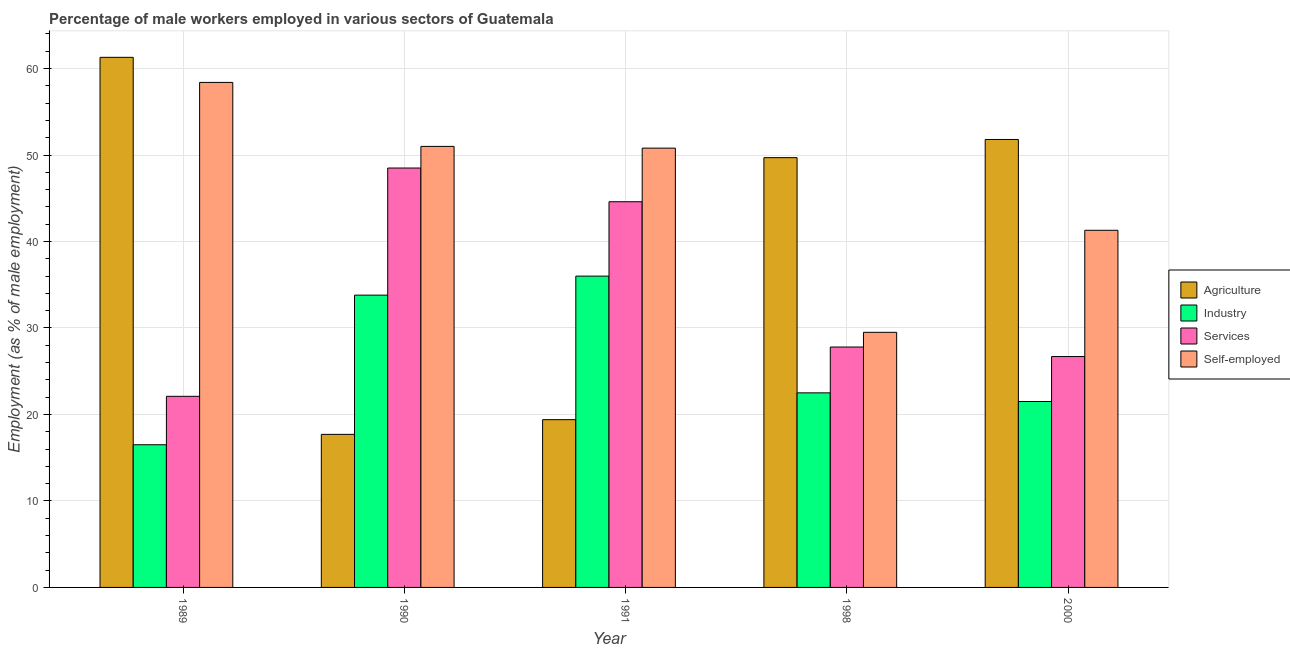How many bars are there on the 4th tick from the left?
Give a very brief answer. 4. What is the percentage of self employed male workers in 1989?
Your response must be concise. 58.4. Across all years, what is the maximum percentage of self employed male workers?
Keep it short and to the point. 58.4. Across all years, what is the minimum percentage of male workers in services?
Offer a terse response. 22.1. In which year was the percentage of male workers in services maximum?
Keep it short and to the point. 1990. What is the total percentage of male workers in industry in the graph?
Offer a very short reply. 130.3. What is the difference between the percentage of male workers in services in 1991 and that in 1998?
Give a very brief answer. 16.8. What is the difference between the percentage of male workers in services in 1990 and the percentage of self employed male workers in 2000?
Your answer should be very brief. 21.8. What is the average percentage of male workers in agriculture per year?
Ensure brevity in your answer.  39.98. In how many years, is the percentage of male workers in industry greater than 50 %?
Your answer should be compact. 0. What is the ratio of the percentage of male workers in services in 1989 to that in 2000?
Your answer should be compact. 0.83. Is the percentage of male workers in agriculture in 1990 less than that in 1991?
Provide a succinct answer. Yes. Is the difference between the percentage of self employed male workers in 1989 and 1991 greater than the difference between the percentage of male workers in agriculture in 1989 and 1991?
Your answer should be compact. No. What is the difference between the highest and the second highest percentage of male workers in agriculture?
Keep it short and to the point. 9.5. What is the difference between the highest and the lowest percentage of male workers in agriculture?
Provide a succinct answer. 43.6. Is the sum of the percentage of self employed male workers in 1991 and 1998 greater than the maximum percentage of male workers in services across all years?
Your response must be concise. Yes. Is it the case that in every year, the sum of the percentage of male workers in services and percentage of self employed male workers is greater than the sum of percentage of male workers in industry and percentage of male workers in agriculture?
Make the answer very short. No. What does the 4th bar from the left in 1990 represents?
Your answer should be very brief. Self-employed. What does the 3rd bar from the right in 2000 represents?
Offer a terse response. Industry. How many years are there in the graph?
Provide a succinct answer. 5. Does the graph contain any zero values?
Your response must be concise. No. Does the graph contain grids?
Your answer should be compact. Yes. Where does the legend appear in the graph?
Make the answer very short. Center right. What is the title of the graph?
Offer a very short reply. Percentage of male workers employed in various sectors of Guatemala. What is the label or title of the X-axis?
Give a very brief answer. Year. What is the label or title of the Y-axis?
Your answer should be very brief. Employment (as % of male employment). What is the Employment (as % of male employment) of Agriculture in 1989?
Give a very brief answer. 61.3. What is the Employment (as % of male employment) of Industry in 1989?
Give a very brief answer. 16.5. What is the Employment (as % of male employment) of Services in 1989?
Give a very brief answer. 22.1. What is the Employment (as % of male employment) in Self-employed in 1989?
Your response must be concise. 58.4. What is the Employment (as % of male employment) in Agriculture in 1990?
Make the answer very short. 17.7. What is the Employment (as % of male employment) in Industry in 1990?
Provide a short and direct response. 33.8. What is the Employment (as % of male employment) of Services in 1990?
Offer a very short reply. 48.5. What is the Employment (as % of male employment) of Agriculture in 1991?
Your answer should be compact. 19.4. What is the Employment (as % of male employment) in Industry in 1991?
Make the answer very short. 36. What is the Employment (as % of male employment) of Services in 1991?
Your response must be concise. 44.6. What is the Employment (as % of male employment) in Self-employed in 1991?
Your response must be concise. 50.8. What is the Employment (as % of male employment) in Agriculture in 1998?
Give a very brief answer. 49.7. What is the Employment (as % of male employment) in Services in 1998?
Ensure brevity in your answer.  27.8. What is the Employment (as % of male employment) in Self-employed in 1998?
Give a very brief answer. 29.5. What is the Employment (as % of male employment) of Agriculture in 2000?
Your answer should be very brief. 51.8. What is the Employment (as % of male employment) in Services in 2000?
Make the answer very short. 26.7. What is the Employment (as % of male employment) in Self-employed in 2000?
Make the answer very short. 41.3. Across all years, what is the maximum Employment (as % of male employment) of Agriculture?
Ensure brevity in your answer.  61.3. Across all years, what is the maximum Employment (as % of male employment) of Services?
Provide a succinct answer. 48.5. Across all years, what is the maximum Employment (as % of male employment) in Self-employed?
Give a very brief answer. 58.4. Across all years, what is the minimum Employment (as % of male employment) of Agriculture?
Your answer should be compact. 17.7. Across all years, what is the minimum Employment (as % of male employment) of Services?
Offer a terse response. 22.1. Across all years, what is the minimum Employment (as % of male employment) of Self-employed?
Your response must be concise. 29.5. What is the total Employment (as % of male employment) of Agriculture in the graph?
Give a very brief answer. 199.9. What is the total Employment (as % of male employment) in Industry in the graph?
Your answer should be very brief. 130.3. What is the total Employment (as % of male employment) of Services in the graph?
Offer a very short reply. 169.7. What is the total Employment (as % of male employment) in Self-employed in the graph?
Your answer should be very brief. 231. What is the difference between the Employment (as % of male employment) in Agriculture in 1989 and that in 1990?
Keep it short and to the point. 43.6. What is the difference between the Employment (as % of male employment) of Industry in 1989 and that in 1990?
Your answer should be very brief. -17.3. What is the difference between the Employment (as % of male employment) of Services in 1989 and that in 1990?
Ensure brevity in your answer.  -26.4. What is the difference between the Employment (as % of male employment) of Agriculture in 1989 and that in 1991?
Offer a terse response. 41.9. What is the difference between the Employment (as % of male employment) in Industry in 1989 and that in 1991?
Your response must be concise. -19.5. What is the difference between the Employment (as % of male employment) of Services in 1989 and that in 1991?
Give a very brief answer. -22.5. What is the difference between the Employment (as % of male employment) in Self-employed in 1989 and that in 1998?
Make the answer very short. 28.9. What is the difference between the Employment (as % of male employment) of Agriculture in 1989 and that in 2000?
Offer a terse response. 9.5. What is the difference between the Employment (as % of male employment) in Industry in 1989 and that in 2000?
Make the answer very short. -5. What is the difference between the Employment (as % of male employment) of Self-employed in 1989 and that in 2000?
Provide a short and direct response. 17.1. What is the difference between the Employment (as % of male employment) of Industry in 1990 and that in 1991?
Provide a short and direct response. -2.2. What is the difference between the Employment (as % of male employment) in Agriculture in 1990 and that in 1998?
Offer a terse response. -32. What is the difference between the Employment (as % of male employment) of Industry in 1990 and that in 1998?
Keep it short and to the point. 11.3. What is the difference between the Employment (as % of male employment) in Services in 1990 and that in 1998?
Offer a very short reply. 20.7. What is the difference between the Employment (as % of male employment) in Agriculture in 1990 and that in 2000?
Give a very brief answer. -34.1. What is the difference between the Employment (as % of male employment) of Industry in 1990 and that in 2000?
Offer a very short reply. 12.3. What is the difference between the Employment (as % of male employment) in Services in 1990 and that in 2000?
Offer a terse response. 21.8. What is the difference between the Employment (as % of male employment) of Agriculture in 1991 and that in 1998?
Offer a very short reply. -30.3. What is the difference between the Employment (as % of male employment) in Self-employed in 1991 and that in 1998?
Ensure brevity in your answer.  21.3. What is the difference between the Employment (as % of male employment) in Agriculture in 1991 and that in 2000?
Keep it short and to the point. -32.4. What is the difference between the Employment (as % of male employment) of Industry in 1991 and that in 2000?
Provide a short and direct response. 14.5. What is the difference between the Employment (as % of male employment) of Services in 1991 and that in 2000?
Offer a terse response. 17.9. What is the difference between the Employment (as % of male employment) in Agriculture in 1998 and that in 2000?
Give a very brief answer. -2.1. What is the difference between the Employment (as % of male employment) of Agriculture in 1989 and the Employment (as % of male employment) of Services in 1990?
Your response must be concise. 12.8. What is the difference between the Employment (as % of male employment) in Agriculture in 1989 and the Employment (as % of male employment) in Self-employed in 1990?
Make the answer very short. 10.3. What is the difference between the Employment (as % of male employment) of Industry in 1989 and the Employment (as % of male employment) of Services in 1990?
Your answer should be very brief. -32. What is the difference between the Employment (as % of male employment) of Industry in 1989 and the Employment (as % of male employment) of Self-employed in 1990?
Your answer should be very brief. -34.5. What is the difference between the Employment (as % of male employment) in Services in 1989 and the Employment (as % of male employment) in Self-employed in 1990?
Your answer should be compact. -28.9. What is the difference between the Employment (as % of male employment) of Agriculture in 1989 and the Employment (as % of male employment) of Industry in 1991?
Ensure brevity in your answer.  25.3. What is the difference between the Employment (as % of male employment) of Agriculture in 1989 and the Employment (as % of male employment) of Services in 1991?
Keep it short and to the point. 16.7. What is the difference between the Employment (as % of male employment) in Industry in 1989 and the Employment (as % of male employment) in Services in 1991?
Make the answer very short. -28.1. What is the difference between the Employment (as % of male employment) in Industry in 1989 and the Employment (as % of male employment) in Self-employed in 1991?
Your response must be concise. -34.3. What is the difference between the Employment (as % of male employment) in Services in 1989 and the Employment (as % of male employment) in Self-employed in 1991?
Keep it short and to the point. -28.7. What is the difference between the Employment (as % of male employment) of Agriculture in 1989 and the Employment (as % of male employment) of Industry in 1998?
Your answer should be very brief. 38.8. What is the difference between the Employment (as % of male employment) of Agriculture in 1989 and the Employment (as % of male employment) of Services in 1998?
Ensure brevity in your answer.  33.5. What is the difference between the Employment (as % of male employment) in Agriculture in 1989 and the Employment (as % of male employment) in Self-employed in 1998?
Offer a very short reply. 31.8. What is the difference between the Employment (as % of male employment) in Industry in 1989 and the Employment (as % of male employment) in Services in 1998?
Give a very brief answer. -11.3. What is the difference between the Employment (as % of male employment) in Industry in 1989 and the Employment (as % of male employment) in Self-employed in 1998?
Your answer should be compact. -13. What is the difference between the Employment (as % of male employment) in Agriculture in 1989 and the Employment (as % of male employment) in Industry in 2000?
Keep it short and to the point. 39.8. What is the difference between the Employment (as % of male employment) of Agriculture in 1989 and the Employment (as % of male employment) of Services in 2000?
Ensure brevity in your answer.  34.6. What is the difference between the Employment (as % of male employment) in Agriculture in 1989 and the Employment (as % of male employment) in Self-employed in 2000?
Ensure brevity in your answer.  20. What is the difference between the Employment (as % of male employment) of Industry in 1989 and the Employment (as % of male employment) of Services in 2000?
Your response must be concise. -10.2. What is the difference between the Employment (as % of male employment) of Industry in 1989 and the Employment (as % of male employment) of Self-employed in 2000?
Offer a terse response. -24.8. What is the difference between the Employment (as % of male employment) of Services in 1989 and the Employment (as % of male employment) of Self-employed in 2000?
Offer a terse response. -19.2. What is the difference between the Employment (as % of male employment) of Agriculture in 1990 and the Employment (as % of male employment) of Industry in 1991?
Give a very brief answer. -18.3. What is the difference between the Employment (as % of male employment) of Agriculture in 1990 and the Employment (as % of male employment) of Services in 1991?
Provide a short and direct response. -26.9. What is the difference between the Employment (as % of male employment) in Agriculture in 1990 and the Employment (as % of male employment) in Self-employed in 1991?
Give a very brief answer. -33.1. What is the difference between the Employment (as % of male employment) in Industry in 1990 and the Employment (as % of male employment) in Services in 1998?
Provide a succinct answer. 6. What is the difference between the Employment (as % of male employment) in Industry in 1990 and the Employment (as % of male employment) in Self-employed in 1998?
Provide a succinct answer. 4.3. What is the difference between the Employment (as % of male employment) in Agriculture in 1990 and the Employment (as % of male employment) in Services in 2000?
Ensure brevity in your answer.  -9. What is the difference between the Employment (as % of male employment) of Agriculture in 1990 and the Employment (as % of male employment) of Self-employed in 2000?
Your answer should be very brief. -23.6. What is the difference between the Employment (as % of male employment) of Industry in 1990 and the Employment (as % of male employment) of Self-employed in 2000?
Offer a very short reply. -7.5. What is the difference between the Employment (as % of male employment) in Services in 1990 and the Employment (as % of male employment) in Self-employed in 2000?
Offer a terse response. 7.2. What is the difference between the Employment (as % of male employment) in Agriculture in 1991 and the Employment (as % of male employment) in Self-employed in 1998?
Provide a succinct answer. -10.1. What is the difference between the Employment (as % of male employment) of Agriculture in 1991 and the Employment (as % of male employment) of Self-employed in 2000?
Your response must be concise. -21.9. What is the difference between the Employment (as % of male employment) in Agriculture in 1998 and the Employment (as % of male employment) in Industry in 2000?
Provide a succinct answer. 28.2. What is the difference between the Employment (as % of male employment) in Agriculture in 1998 and the Employment (as % of male employment) in Self-employed in 2000?
Provide a succinct answer. 8.4. What is the difference between the Employment (as % of male employment) in Industry in 1998 and the Employment (as % of male employment) in Self-employed in 2000?
Give a very brief answer. -18.8. What is the average Employment (as % of male employment) of Agriculture per year?
Offer a terse response. 39.98. What is the average Employment (as % of male employment) in Industry per year?
Your answer should be compact. 26.06. What is the average Employment (as % of male employment) in Services per year?
Your answer should be compact. 33.94. What is the average Employment (as % of male employment) in Self-employed per year?
Give a very brief answer. 46.2. In the year 1989, what is the difference between the Employment (as % of male employment) of Agriculture and Employment (as % of male employment) of Industry?
Make the answer very short. 44.8. In the year 1989, what is the difference between the Employment (as % of male employment) of Agriculture and Employment (as % of male employment) of Services?
Make the answer very short. 39.2. In the year 1989, what is the difference between the Employment (as % of male employment) of Agriculture and Employment (as % of male employment) of Self-employed?
Give a very brief answer. 2.9. In the year 1989, what is the difference between the Employment (as % of male employment) of Industry and Employment (as % of male employment) of Services?
Your answer should be very brief. -5.6. In the year 1989, what is the difference between the Employment (as % of male employment) of Industry and Employment (as % of male employment) of Self-employed?
Provide a short and direct response. -41.9. In the year 1989, what is the difference between the Employment (as % of male employment) of Services and Employment (as % of male employment) of Self-employed?
Offer a terse response. -36.3. In the year 1990, what is the difference between the Employment (as % of male employment) in Agriculture and Employment (as % of male employment) in Industry?
Offer a very short reply. -16.1. In the year 1990, what is the difference between the Employment (as % of male employment) in Agriculture and Employment (as % of male employment) in Services?
Offer a terse response. -30.8. In the year 1990, what is the difference between the Employment (as % of male employment) in Agriculture and Employment (as % of male employment) in Self-employed?
Your answer should be very brief. -33.3. In the year 1990, what is the difference between the Employment (as % of male employment) of Industry and Employment (as % of male employment) of Services?
Provide a short and direct response. -14.7. In the year 1990, what is the difference between the Employment (as % of male employment) in Industry and Employment (as % of male employment) in Self-employed?
Offer a very short reply. -17.2. In the year 1990, what is the difference between the Employment (as % of male employment) of Services and Employment (as % of male employment) of Self-employed?
Offer a terse response. -2.5. In the year 1991, what is the difference between the Employment (as % of male employment) in Agriculture and Employment (as % of male employment) in Industry?
Ensure brevity in your answer.  -16.6. In the year 1991, what is the difference between the Employment (as % of male employment) of Agriculture and Employment (as % of male employment) of Services?
Keep it short and to the point. -25.2. In the year 1991, what is the difference between the Employment (as % of male employment) of Agriculture and Employment (as % of male employment) of Self-employed?
Ensure brevity in your answer.  -31.4. In the year 1991, what is the difference between the Employment (as % of male employment) of Industry and Employment (as % of male employment) of Self-employed?
Keep it short and to the point. -14.8. In the year 1998, what is the difference between the Employment (as % of male employment) in Agriculture and Employment (as % of male employment) in Industry?
Give a very brief answer. 27.2. In the year 1998, what is the difference between the Employment (as % of male employment) in Agriculture and Employment (as % of male employment) in Services?
Offer a terse response. 21.9. In the year 1998, what is the difference between the Employment (as % of male employment) in Agriculture and Employment (as % of male employment) in Self-employed?
Give a very brief answer. 20.2. In the year 1998, what is the difference between the Employment (as % of male employment) in Industry and Employment (as % of male employment) in Services?
Ensure brevity in your answer.  -5.3. In the year 1998, what is the difference between the Employment (as % of male employment) of Industry and Employment (as % of male employment) of Self-employed?
Give a very brief answer. -7. In the year 1998, what is the difference between the Employment (as % of male employment) in Services and Employment (as % of male employment) in Self-employed?
Offer a very short reply. -1.7. In the year 2000, what is the difference between the Employment (as % of male employment) of Agriculture and Employment (as % of male employment) of Industry?
Make the answer very short. 30.3. In the year 2000, what is the difference between the Employment (as % of male employment) of Agriculture and Employment (as % of male employment) of Services?
Provide a succinct answer. 25.1. In the year 2000, what is the difference between the Employment (as % of male employment) of Agriculture and Employment (as % of male employment) of Self-employed?
Offer a terse response. 10.5. In the year 2000, what is the difference between the Employment (as % of male employment) in Industry and Employment (as % of male employment) in Self-employed?
Your response must be concise. -19.8. In the year 2000, what is the difference between the Employment (as % of male employment) in Services and Employment (as % of male employment) in Self-employed?
Give a very brief answer. -14.6. What is the ratio of the Employment (as % of male employment) in Agriculture in 1989 to that in 1990?
Give a very brief answer. 3.46. What is the ratio of the Employment (as % of male employment) in Industry in 1989 to that in 1990?
Offer a very short reply. 0.49. What is the ratio of the Employment (as % of male employment) of Services in 1989 to that in 1990?
Provide a short and direct response. 0.46. What is the ratio of the Employment (as % of male employment) in Self-employed in 1989 to that in 1990?
Provide a succinct answer. 1.15. What is the ratio of the Employment (as % of male employment) of Agriculture in 1989 to that in 1991?
Your answer should be very brief. 3.16. What is the ratio of the Employment (as % of male employment) of Industry in 1989 to that in 1991?
Make the answer very short. 0.46. What is the ratio of the Employment (as % of male employment) in Services in 1989 to that in 1991?
Offer a terse response. 0.5. What is the ratio of the Employment (as % of male employment) in Self-employed in 1989 to that in 1991?
Your answer should be compact. 1.15. What is the ratio of the Employment (as % of male employment) of Agriculture in 1989 to that in 1998?
Ensure brevity in your answer.  1.23. What is the ratio of the Employment (as % of male employment) of Industry in 1989 to that in 1998?
Provide a succinct answer. 0.73. What is the ratio of the Employment (as % of male employment) in Services in 1989 to that in 1998?
Make the answer very short. 0.8. What is the ratio of the Employment (as % of male employment) of Self-employed in 1989 to that in 1998?
Offer a very short reply. 1.98. What is the ratio of the Employment (as % of male employment) of Agriculture in 1989 to that in 2000?
Your answer should be very brief. 1.18. What is the ratio of the Employment (as % of male employment) in Industry in 1989 to that in 2000?
Offer a very short reply. 0.77. What is the ratio of the Employment (as % of male employment) in Services in 1989 to that in 2000?
Your response must be concise. 0.83. What is the ratio of the Employment (as % of male employment) of Self-employed in 1989 to that in 2000?
Provide a succinct answer. 1.41. What is the ratio of the Employment (as % of male employment) in Agriculture in 1990 to that in 1991?
Offer a terse response. 0.91. What is the ratio of the Employment (as % of male employment) of Industry in 1990 to that in 1991?
Give a very brief answer. 0.94. What is the ratio of the Employment (as % of male employment) in Services in 1990 to that in 1991?
Ensure brevity in your answer.  1.09. What is the ratio of the Employment (as % of male employment) in Self-employed in 1990 to that in 1991?
Give a very brief answer. 1. What is the ratio of the Employment (as % of male employment) in Agriculture in 1990 to that in 1998?
Your answer should be very brief. 0.36. What is the ratio of the Employment (as % of male employment) of Industry in 1990 to that in 1998?
Your response must be concise. 1.5. What is the ratio of the Employment (as % of male employment) in Services in 1990 to that in 1998?
Offer a very short reply. 1.74. What is the ratio of the Employment (as % of male employment) of Self-employed in 1990 to that in 1998?
Ensure brevity in your answer.  1.73. What is the ratio of the Employment (as % of male employment) of Agriculture in 1990 to that in 2000?
Ensure brevity in your answer.  0.34. What is the ratio of the Employment (as % of male employment) in Industry in 1990 to that in 2000?
Provide a succinct answer. 1.57. What is the ratio of the Employment (as % of male employment) of Services in 1990 to that in 2000?
Give a very brief answer. 1.82. What is the ratio of the Employment (as % of male employment) of Self-employed in 1990 to that in 2000?
Provide a succinct answer. 1.23. What is the ratio of the Employment (as % of male employment) in Agriculture in 1991 to that in 1998?
Make the answer very short. 0.39. What is the ratio of the Employment (as % of male employment) of Services in 1991 to that in 1998?
Offer a very short reply. 1.6. What is the ratio of the Employment (as % of male employment) of Self-employed in 1991 to that in 1998?
Your answer should be very brief. 1.72. What is the ratio of the Employment (as % of male employment) of Agriculture in 1991 to that in 2000?
Your answer should be compact. 0.37. What is the ratio of the Employment (as % of male employment) in Industry in 1991 to that in 2000?
Your response must be concise. 1.67. What is the ratio of the Employment (as % of male employment) of Services in 1991 to that in 2000?
Ensure brevity in your answer.  1.67. What is the ratio of the Employment (as % of male employment) of Self-employed in 1991 to that in 2000?
Offer a very short reply. 1.23. What is the ratio of the Employment (as % of male employment) of Agriculture in 1998 to that in 2000?
Make the answer very short. 0.96. What is the ratio of the Employment (as % of male employment) of Industry in 1998 to that in 2000?
Give a very brief answer. 1.05. What is the ratio of the Employment (as % of male employment) of Services in 1998 to that in 2000?
Make the answer very short. 1.04. What is the ratio of the Employment (as % of male employment) in Self-employed in 1998 to that in 2000?
Offer a very short reply. 0.71. What is the difference between the highest and the second highest Employment (as % of male employment) of Agriculture?
Provide a short and direct response. 9.5. What is the difference between the highest and the second highest Employment (as % of male employment) of Self-employed?
Give a very brief answer. 7.4. What is the difference between the highest and the lowest Employment (as % of male employment) of Agriculture?
Offer a terse response. 43.6. What is the difference between the highest and the lowest Employment (as % of male employment) in Industry?
Provide a succinct answer. 19.5. What is the difference between the highest and the lowest Employment (as % of male employment) in Services?
Keep it short and to the point. 26.4. What is the difference between the highest and the lowest Employment (as % of male employment) in Self-employed?
Offer a very short reply. 28.9. 